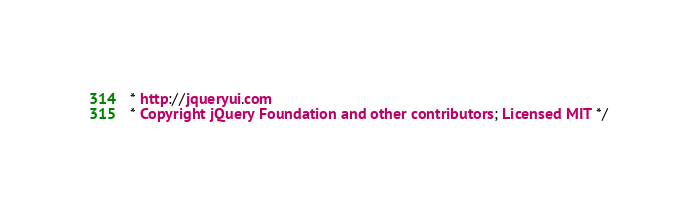<code> <loc_0><loc_0><loc_500><loc_500><_CSS_>* http://jqueryui.com
* Copyright jQuery Foundation and other contributors; Licensed MIT */
</code> 